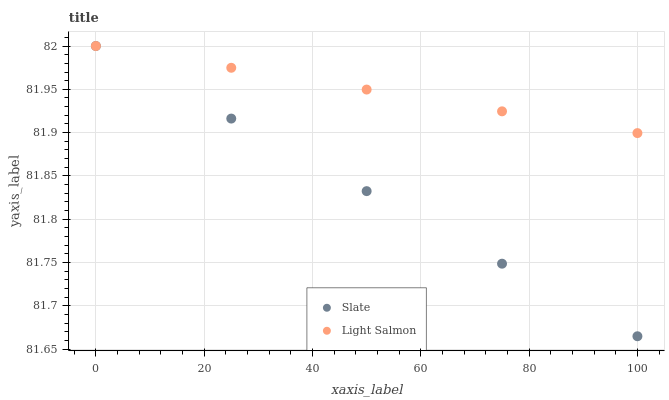Does Slate have the minimum area under the curve?
Answer yes or no. Yes. Does Light Salmon have the maximum area under the curve?
Answer yes or no. Yes. Does Light Salmon have the minimum area under the curve?
Answer yes or no. No. Is Light Salmon the smoothest?
Answer yes or no. Yes. Is Slate the roughest?
Answer yes or no. Yes. Is Light Salmon the roughest?
Answer yes or no. No. Does Slate have the lowest value?
Answer yes or no. Yes. Does Light Salmon have the lowest value?
Answer yes or no. No. Does Light Salmon have the highest value?
Answer yes or no. Yes. Does Light Salmon intersect Slate?
Answer yes or no. Yes. Is Light Salmon less than Slate?
Answer yes or no. No. Is Light Salmon greater than Slate?
Answer yes or no. No. 